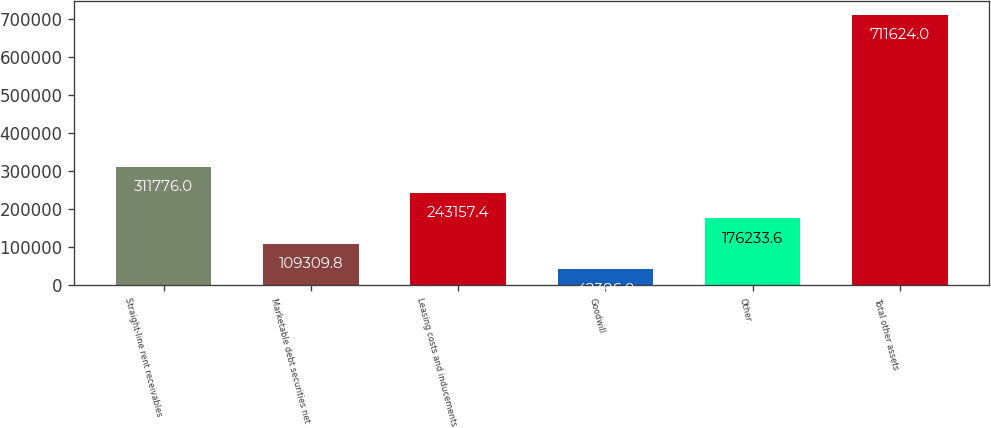<chart> <loc_0><loc_0><loc_500><loc_500><bar_chart><fcel>Straight-line rent receivables<fcel>Marketable debt securities net<fcel>Leasing costs and inducements<fcel>Goodwill<fcel>Other<fcel>Total other assets<nl><fcel>311776<fcel>109310<fcel>243157<fcel>42386<fcel>176234<fcel>711624<nl></chart> 